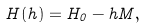Convert formula to latex. <formula><loc_0><loc_0><loc_500><loc_500>H ( h ) = H _ { 0 } - h M ,</formula> 